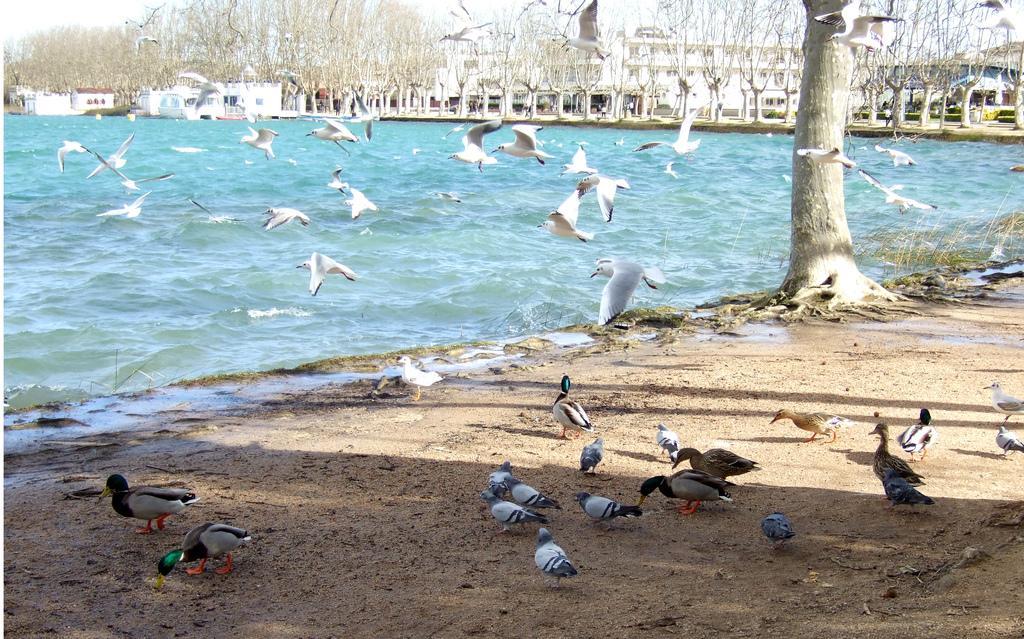Please provide a concise description of this image. In this picture, we can see a few birds, ground, trees plants, water, buildings, and a few people, we can see the sky. 